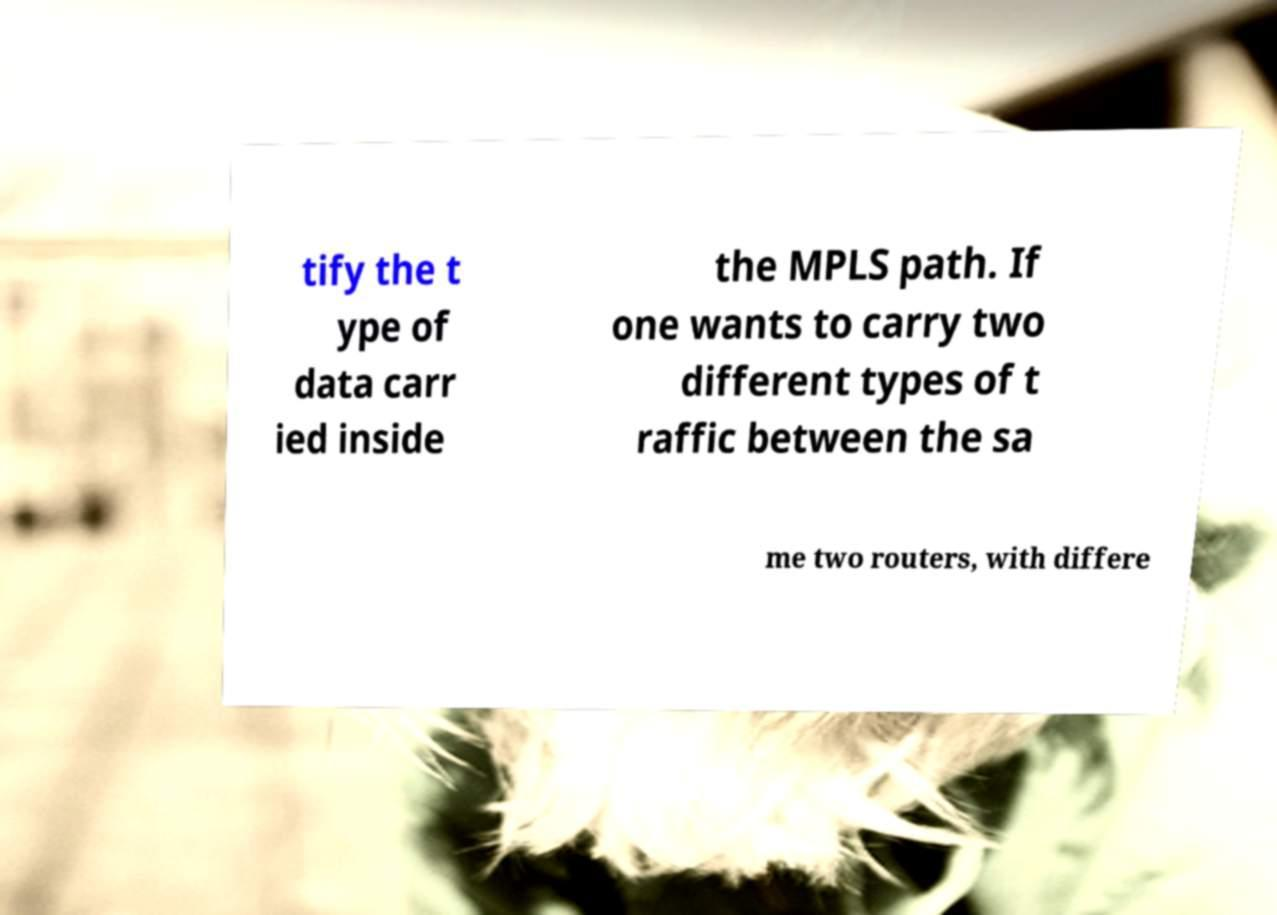Please read and relay the text visible in this image. What does it say? tify the t ype of data carr ied inside the MPLS path. If one wants to carry two different types of t raffic between the sa me two routers, with differe 